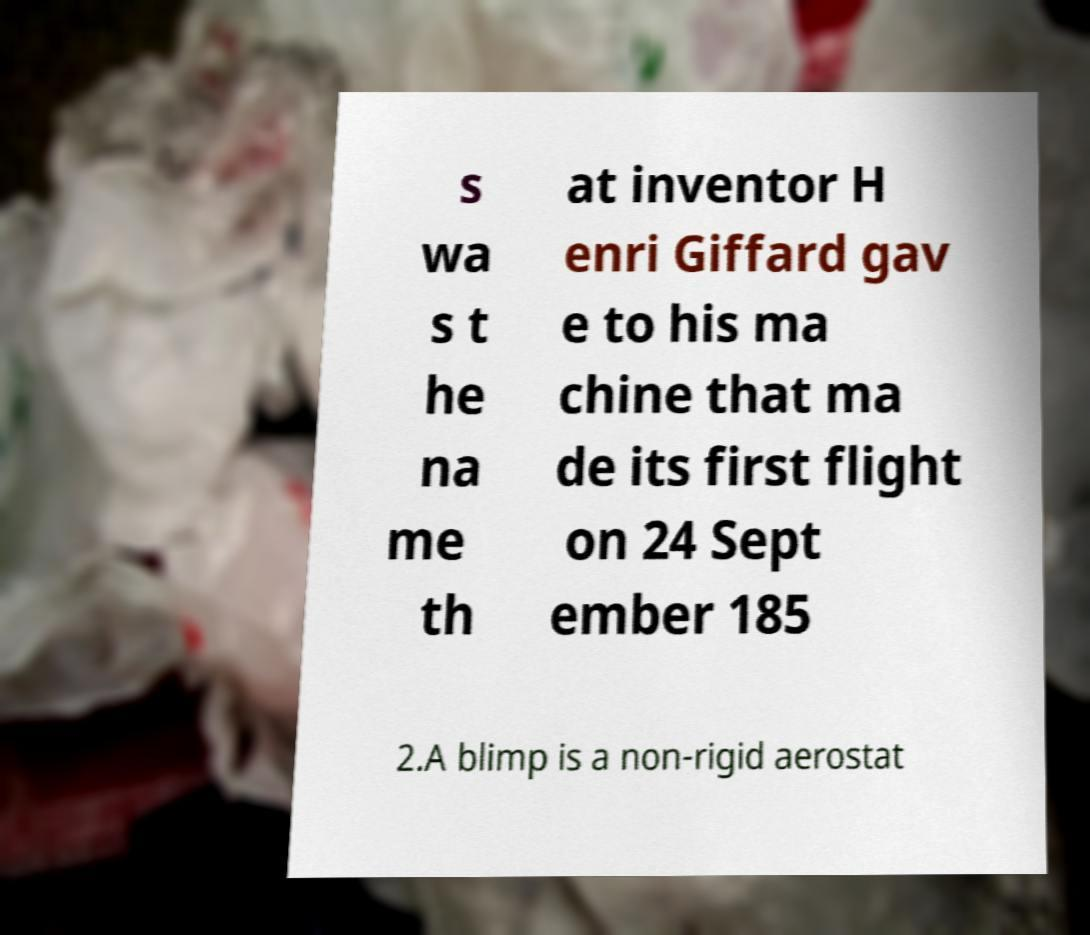Can you accurately transcribe the text from the provided image for me? s wa s t he na me th at inventor H enri Giffard gav e to his ma chine that ma de its first flight on 24 Sept ember 185 2.A blimp is a non-rigid aerostat 